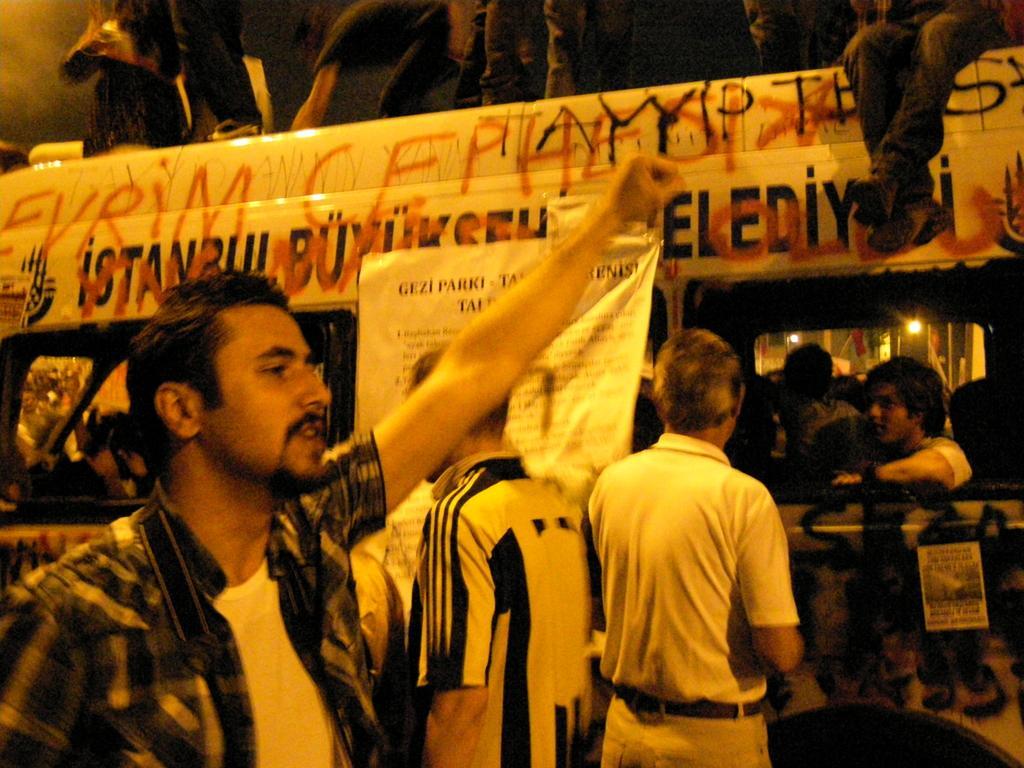Describe this image in one or two sentences. In the foreground of this image, on the left, there is a man with one hand raised in the air. In the background, there are people in a vehicle on which there is some text. We can also see two men standing, a banner and few people at the top of a vehicle. 